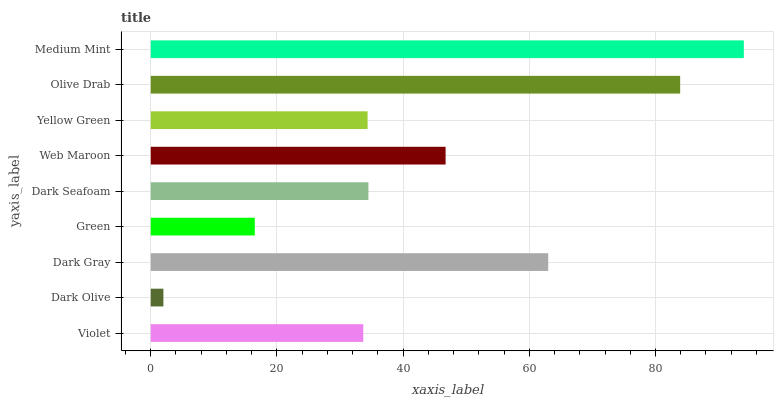Is Dark Olive the minimum?
Answer yes or no. Yes. Is Medium Mint the maximum?
Answer yes or no. Yes. Is Dark Gray the minimum?
Answer yes or no. No. Is Dark Gray the maximum?
Answer yes or no. No. Is Dark Gray greater than Dark Olive?
Answer yes or no. Yes. Is Dark Olive less than Dark Gray?
Answer yes or no. Yes. Is Dark Olive greater than Dark Gray?
Answer yes or no. No. Is Dark Gray less than Dark Olive?
Answer yes or no. No. Is Dark Seafoam the high median?
Answer yes or no. Yes. Is Dark Seafoam the low median?
Answer yes or no. Yes. Is Green the high median?
Answer yes or no. No. Is Green the low median?
Answer yes or no. No. 